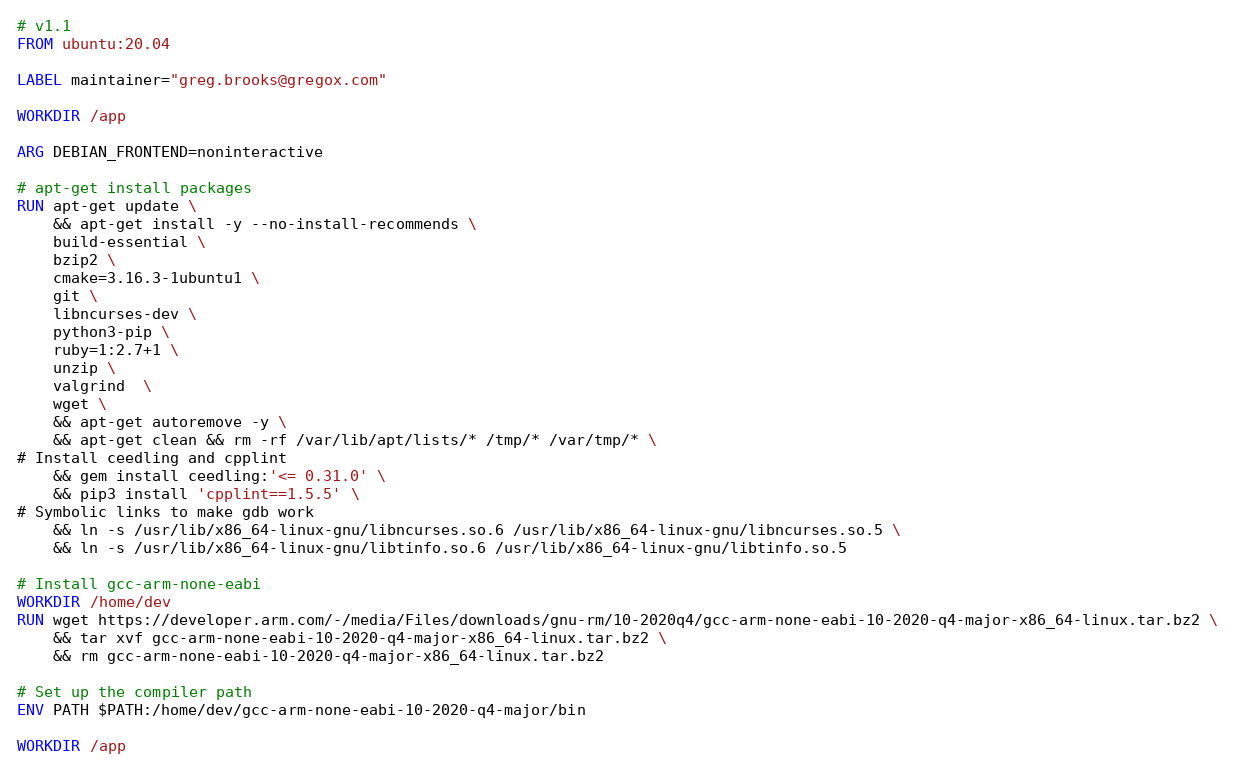Convert code to text. <code><loc_0><loc_0><loc_500><loc_500><_Dockerfile_># v1.1
FROM ubuntu:20.04

LABEL maintainer="greg.brooks@gregox.com"

WORKDIR /app

ARG DEBIAN_FRONTEND=noninteractive

# apt-get install packages
RUN apt-get update \
    && apt-get install -y --no-install-recommends \
    build-essential \
    bzip2 \
    cmake=3.16.3-1ubuntu1 \
    git \
    libncurses-dev \
    python3-pip \
    ruby=1:2.7+1 \
    unzip \
    valgrind  \
    wget \
    && apt-get autoremove -y \
    && apt-get clean && rm -rf /var/lib/apt/lists/* /tmp/* /var/tmp/* \
# Install ceedling and cpplint
    && gem install ceedling:'<= 0.31.0' \
    && pip3 install 'cpplint==1.5.5' \
# Symbolic links to make gdb work
    && ln -s /usr/lib/x86_64-linux-gnu/libncurses.so.6 /usr/lib/x86_64-linux-gnu/libncurses.so.5 \
    && ln -s /usr/lib/x86_64-linux-gnu/libtinfo.so.6 /usr/lib/x86_64-linux-gnu/libtinfo.so.5

# Install gcc-arm-none-eabi
WORKDIR /home/dev
RUN wget https://developer.arm.com/-/media/Files/downloads/gnu-rm/10-2020q4/gcc-arm-none-eabi-10-2020-q4-major-x86_64-linux.tar.bz2 \
    && tar xvf gcc-arm-none-eabi-10-2020-q4-major-x86_64-linux.tar.bz2 \
    && rm gcc-arm-none-eabi-10-2020-q4-major-x86_64-linux.tar.bz2

# Set up the compiler path
ENV PATH $PATH:/home/dev/gcc-arm-none-eabi-10-2020-q4-major/bin

WORKDIR /app</code> 